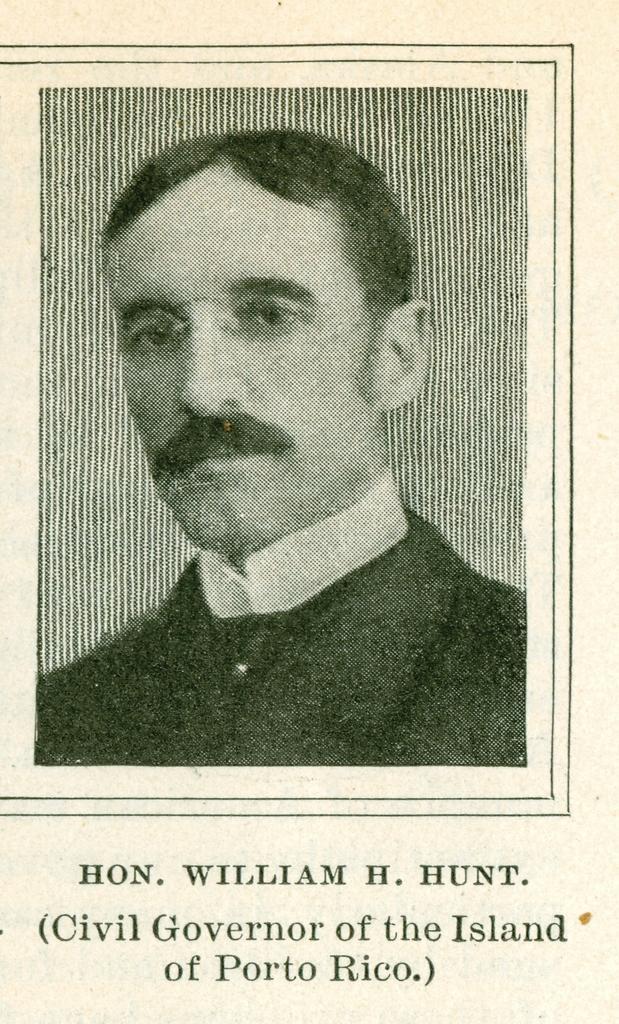Describe this image in one or two sentences. In this image we can see a black and white picture of a person. On the bottom of the image we can see some text. 